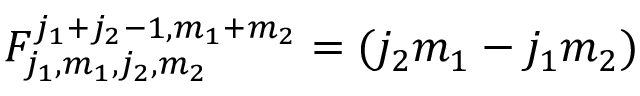<formula> <loc_0><loc_0><loc_500><loc_500>F _ { j _ { 1 } , m _ { 1 } , j _ { 2 } , m _ { 2 } } ^ { j _ { 1 } + j _ { 2 } - 1 , m _ { 1 } + m _ { 2 } } = ( j _ { 2 } m _ { 1 } - j _ { 1 } m _ { 2 } )</formula> 